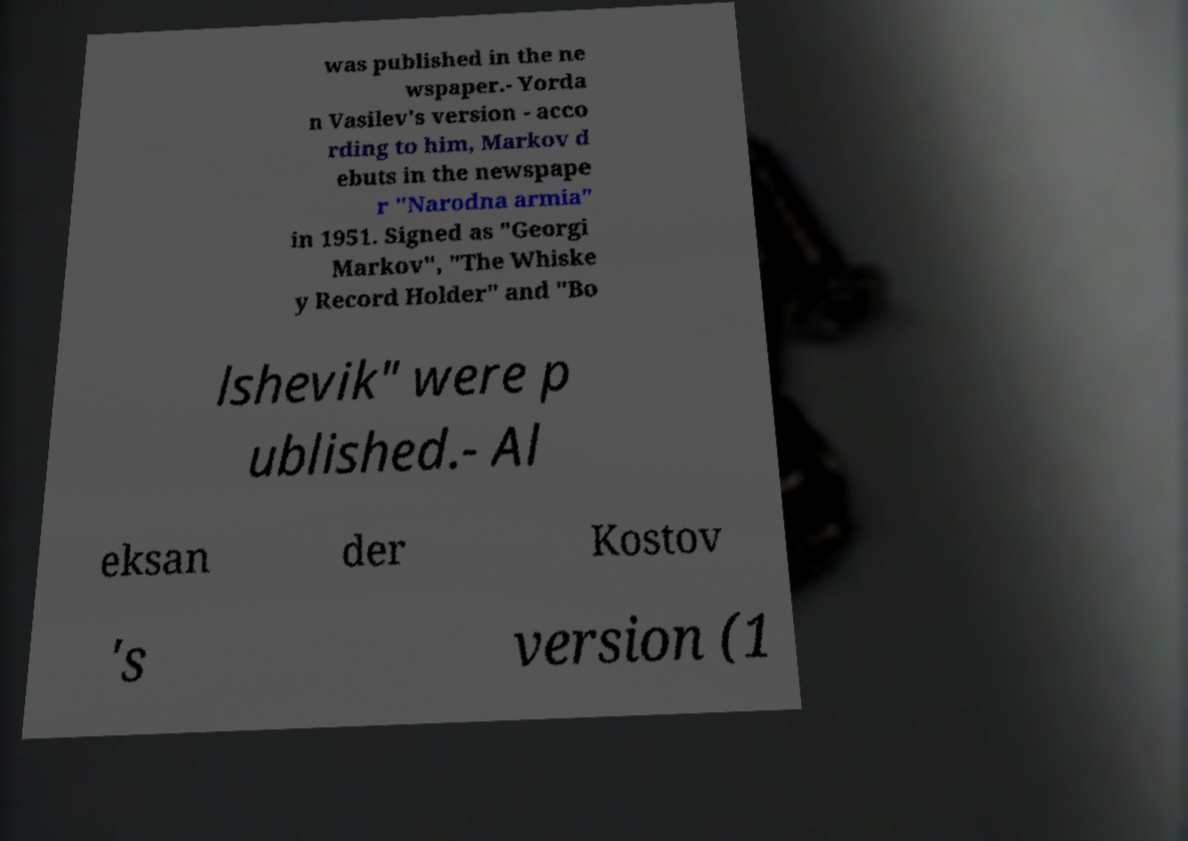Can you read and provide the text displayed in the image?This photo seems to have some interesting text. Can you extract and type it out for me? was published in the ne wspaper.- Yorda n Vasilev's version - acco rding to him, Markov d ebuts in the newspape r "Narodna armia" in 1951. Signed as "Georgi Markov", "The Whiske y Record Holder" and "Bo lshevik" were p ublished.- Al eksan der Kostov 's version (1 